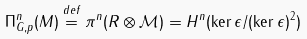Convert formula to latex. <formula><loc_0><loc_0><loc_500><loc_500>\Pi ^ { n } _ { G , p } ( M ) \overset { d e f } { = } \pi ^ { n } ( R \otimes \mathcal { M } ) = H ^ { n } ( \ker \epsilon / ( \ker \epsilon ) ^ { 2 } )</formula> 